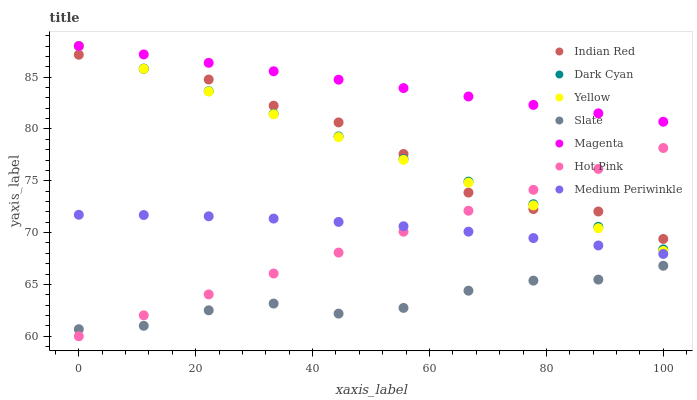Does Slate have the minimum area under the curve?
Answer yes or no. Yes. Does Magenta have the maximum area under the curve?
Answer yes or no. Yes. Does Hot Pink have the minimum area under the curve?
Answer yes or no. No. Does Hot Pink have the maximum area under the curve?
Answer yes or no. No. Is Dark Cyan the smoothest?
Answer yes or no. Yes. Is Indian Red the roughest?
Answer yes or no. Yes. Is Hot Pink the smoothest?
Answer yes or no. No. Is Hot Pink the roughest?
Answer yes or no. No. Does Hot Pink have the lowest value?
Answer yes or no. Yes. Does Medium Periwinkle have the lowest value?
Answer yes or no. No. Does Magenta have the highest value?
Answer yes or no. Yes. Does Hot Pink have the highest value?
Answer yes or no. No. Is Indian Red less than Magenta?
Answer yes or no. Yes. Is Medium Periwinkle greater than Slate?
Answer yes or no. Yes. Does Magenta intersect Yellow?
Answer yes or no. Yes. Is Magenta less than Yellow?
Answer yes or no. No. Is Magenta greater than Yellow?
Answer yes or no. No. Does Indian Red intersect Magenta?
Answer yes or no. No. 